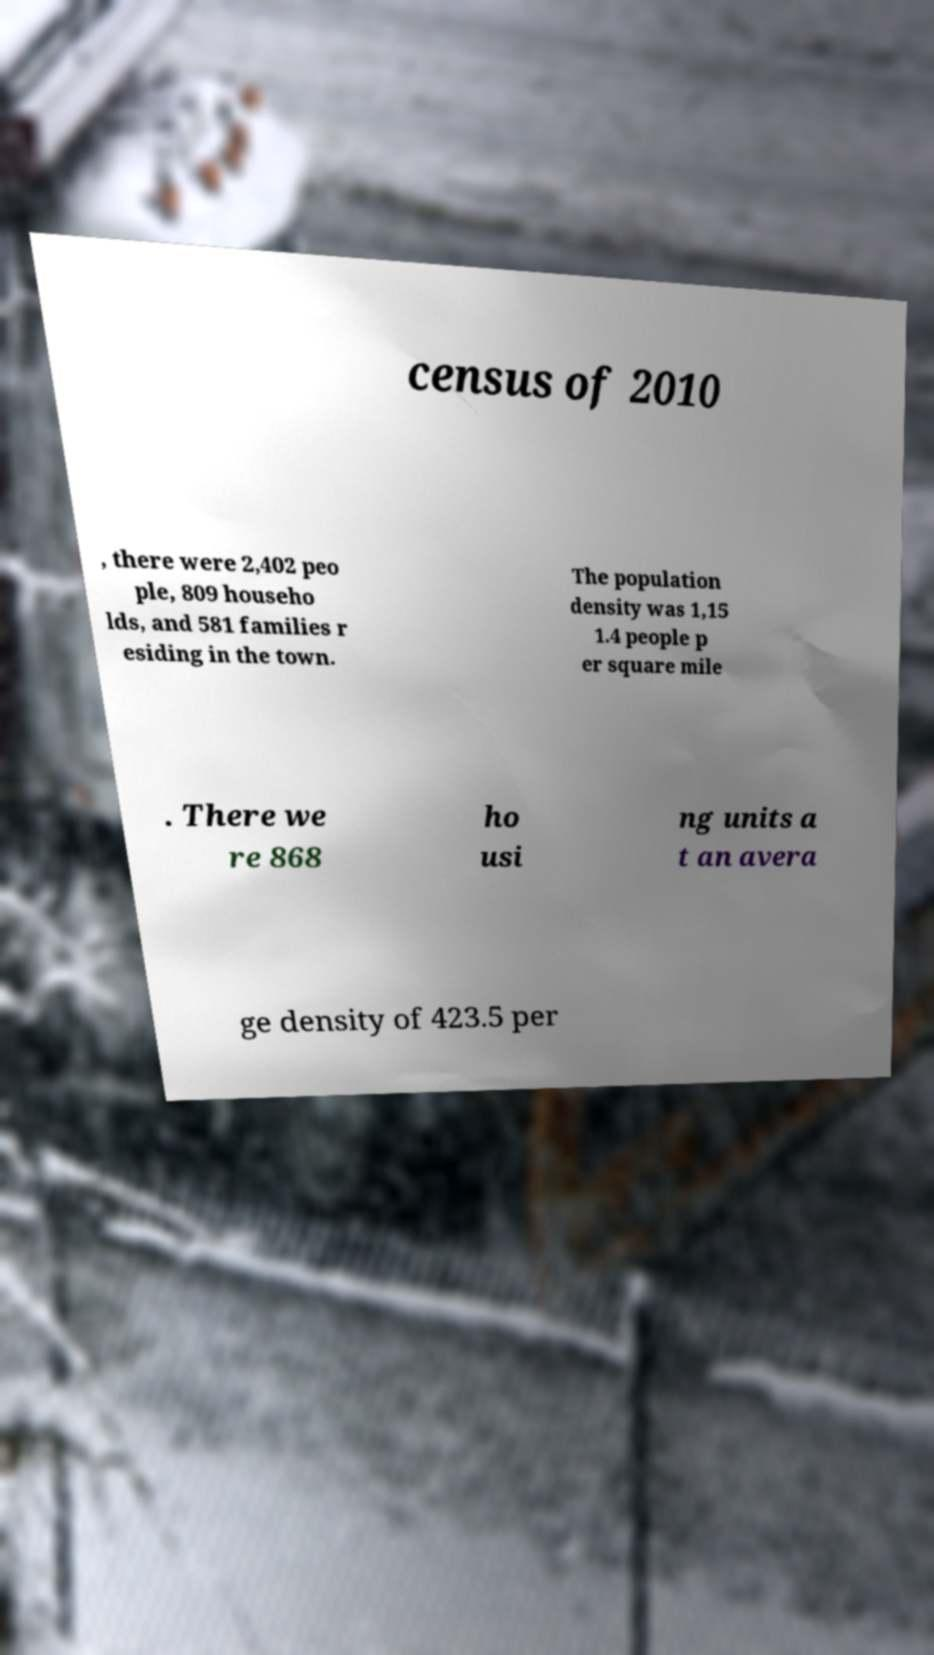Could you assist in decoding the text presented in this image and type it out clearly? census of 2010 , there were 2,402 peo ple, 809 househo lds, and 581 families r esiding in the town. The population density was 1,15 1.4 people p er square mile . There we re 868 ho usi ng units a t an avera ge density of 423.5 per 